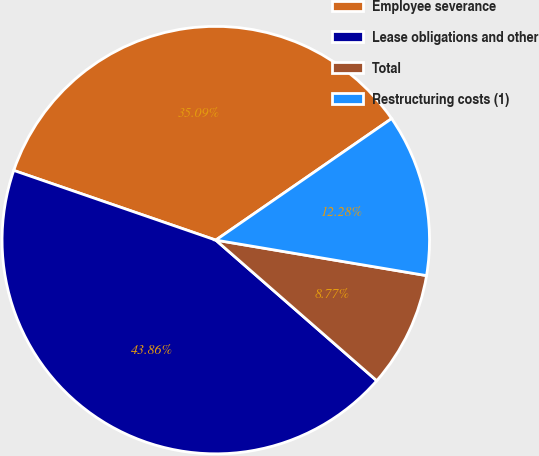<chart> <loc_0><loc_0><loc_500><loc_500><pie_chart><fcel>Employee severance<fcel>Lease obligations and other<fcel>Total<fcel>Restructuring costs (1)<nl><fcel>35.09%<fcel>43.86%<fcel>8.77%<fcel>12.28%<nl></chart> 